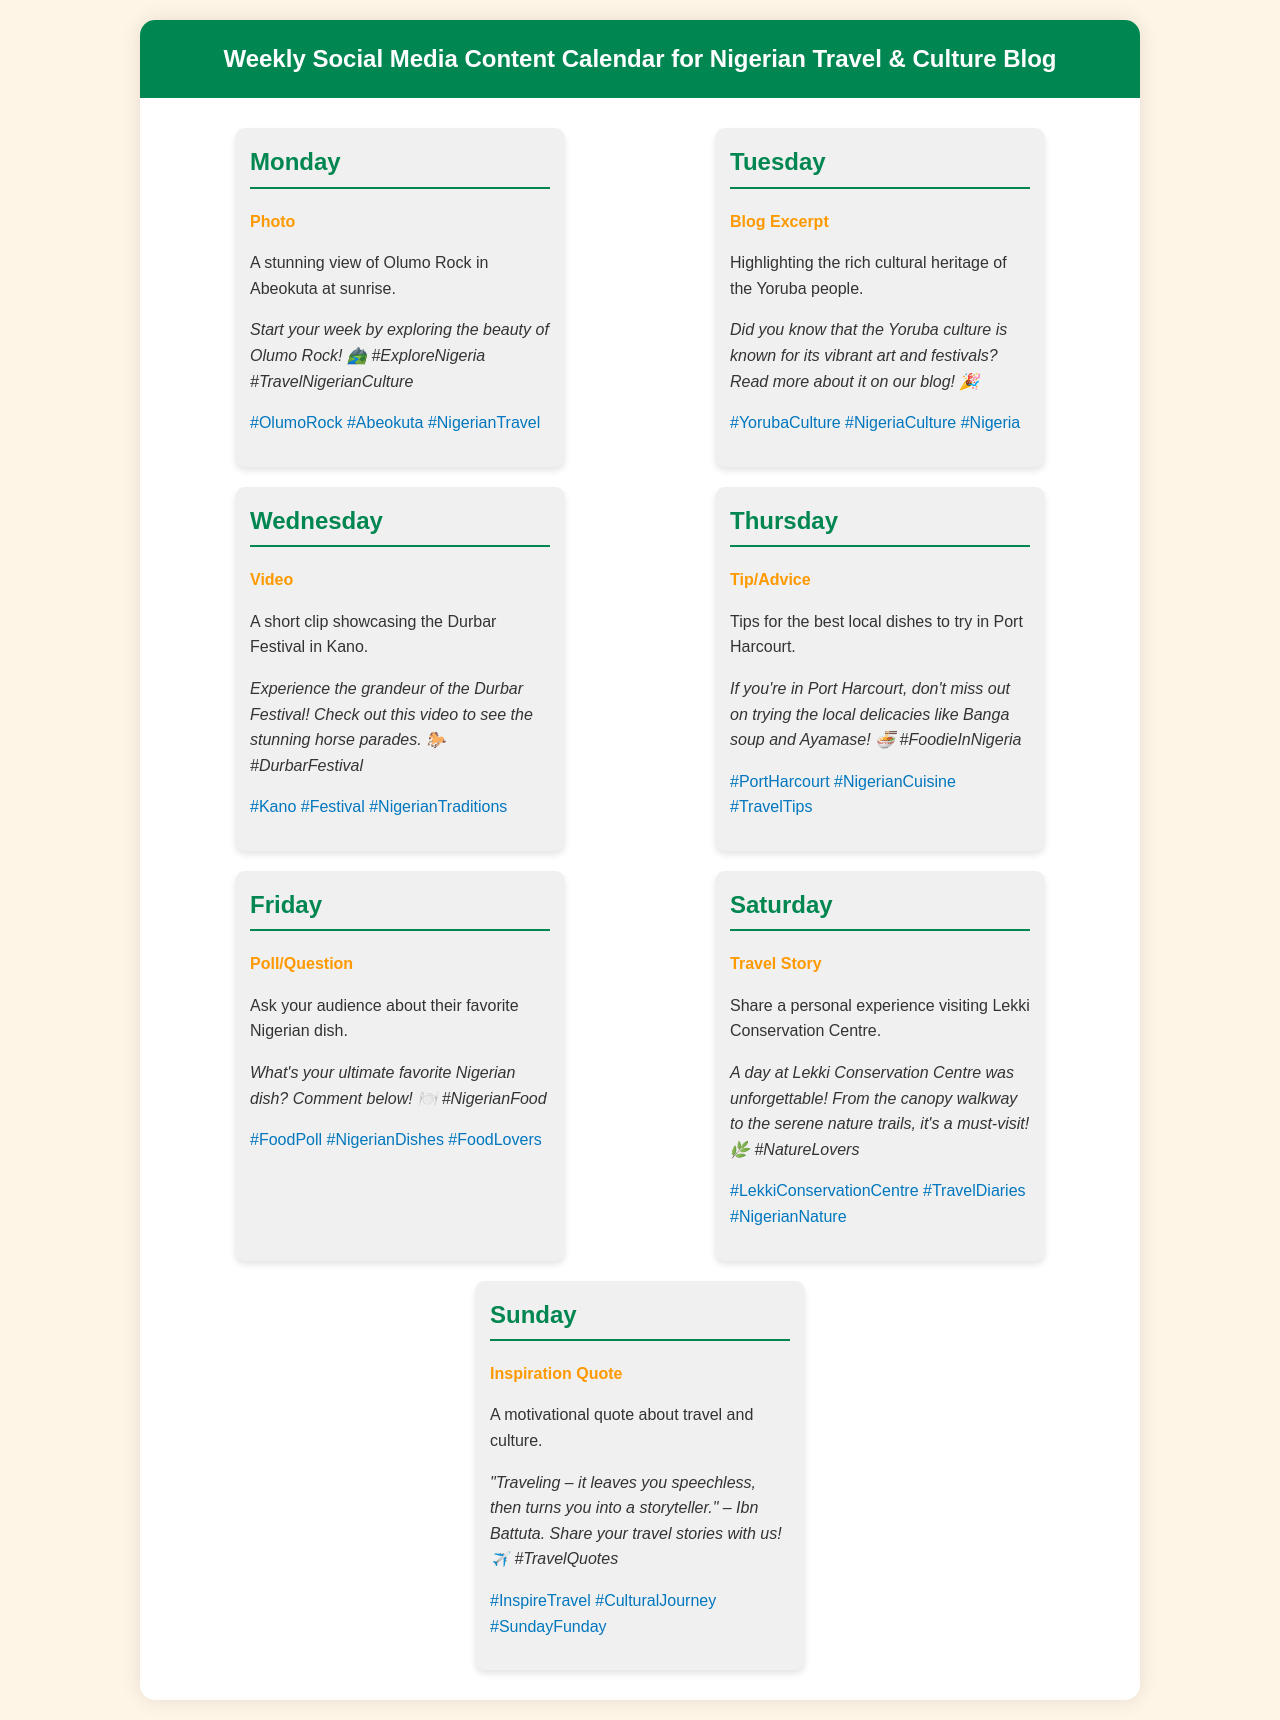What is the first post of the week? The first post of the week is scheduled for Monday, which features a photo of Olumo Rock at sunrise.
Answer: A stunning view of Olumo Rock in Abeokuta at sunrise What type of post is featured on Tuesday? The post featured on Tuesday is a blog excerpt regarding Yoruba culture.
Answer: Blog Excerpt What festival is showcased in the Wednesday video? The video on Wednesday showcases the Durbar Festival held in Kano.
Answer: Durbar Festival What food is recommended to try in Port Harcourt? The recommended local dishes to try in Port Harcourt include Banga soup and Ayamase.
Answer: Banga soup and Ayamase What type of content is shared on Saturday? The content shared on Saturday is a travel story about visiting Lekki Conservation Centre.
Answer: Travel Story How many reviews are discussed in this content calendar? The content calendar does not mention any specific number of reviews; it primarily presents unique posts for each day.
Answer: None What motivational quote is shared on Sunday? The quote shared includes references to travel and storytelling, attributed to Ibn Battuta.
Answer: "Traveling – it leaves you speechless, then turns you into a storyteller." What element is included in Friday's engagement post? Friday includes a poll asking the audience about their favorite Nigerian dish.
Answer: Poll/Question 